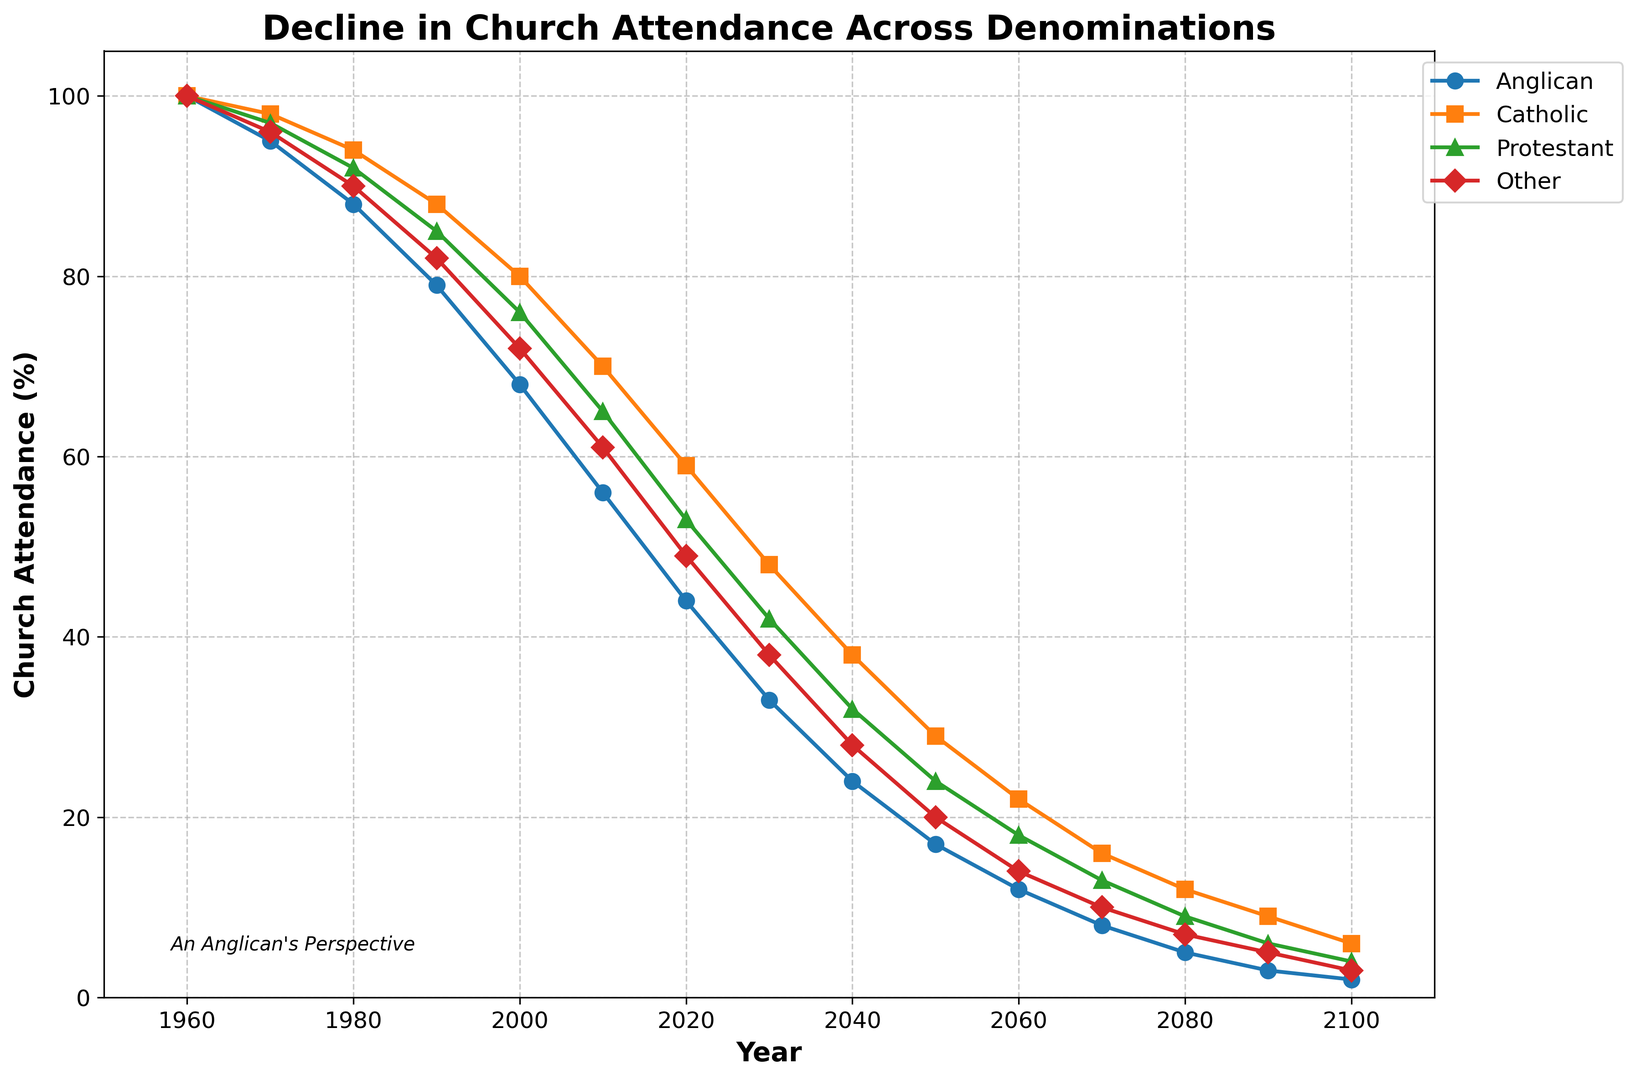What's the trend in church attendance for all denominations after 2000? All denominations show a continuous decline in church attendance after the year 2000. This is evident from the decreasing lines for each denomination, which get progressively lower over the years.
Answer: Continuous decline Which denomination has the steepest decline in attendance from 1960 to 2100? The Anglican denomination shows the steepest decline in attendance from 100% in 1960 to 2% in 2100. This is steeper than all other denominations which decline more moderately.
Answer: Anglican Between the years 2040 and 2050, which denomination experiences the smallest decrease in attendance? By comparing the values: Anglican (24 to 17), Catholic (38 to 29), Protestant (32 to 24), and Other (28 to 20). Catholic shows the smallest decrease from 38% to 29%, a difference of 9%.
Answer: Catholic Which denomination is projected to have the highest attendance percentage in the year 2100? In the year 2100, the Catholic denomination is projected to have the highest attendance percentage at 6%. This is higher than Anglican (2%), Protestant (4%), and Other (3%).
Answer: Catholic By what percentage has Anglican attendance decreased from 1960 to 2020? Anglican attendance decreases from 100% in 1960 to 44% in 2020. The percentage decrease is (100 - 44) = 56%.
Answer: 56% What is the combined church attendance for all denominations in 2030? Adding the attendance percentages: Anglican (33), Catholic (48), Protestant (42), and Other (38), the combined attendance is 33 + 48 + 42 + 38 = 161%.
Answer: 161% What is the rate of decline in Protestant attendance from 1980 to 2010? Protestant attendance declines from 92% in 1980 to 65% in 2010. The rate of decline over 30 years is (92 - 65) / 30 = 0.9% per year.
Answer: 0.9% per year What visual indication helps identify the Catholic denomination's curve? The Catholic denomination's curve is indicated with an orange color and a square marker on the plot. This distinguishes it from the other denominations.
Answer: Orange color and square marker Which denomination shows a crossover point with another denomination and when does it occur? Protestant attendance crosses below Catholic attendance between 1970 and 1980. This is observed as the Protestant curve dips below the Catholic curve in this period.
Answer: Protestant, between 1970 and 1980 If current trends hold, which denomination will first dip below 10% attendance and in which year? Anglican attendance is projected to dip below 10% attendance first, around the year 2070 when it drops to 8%.
Answer: Anglican, around 2070 